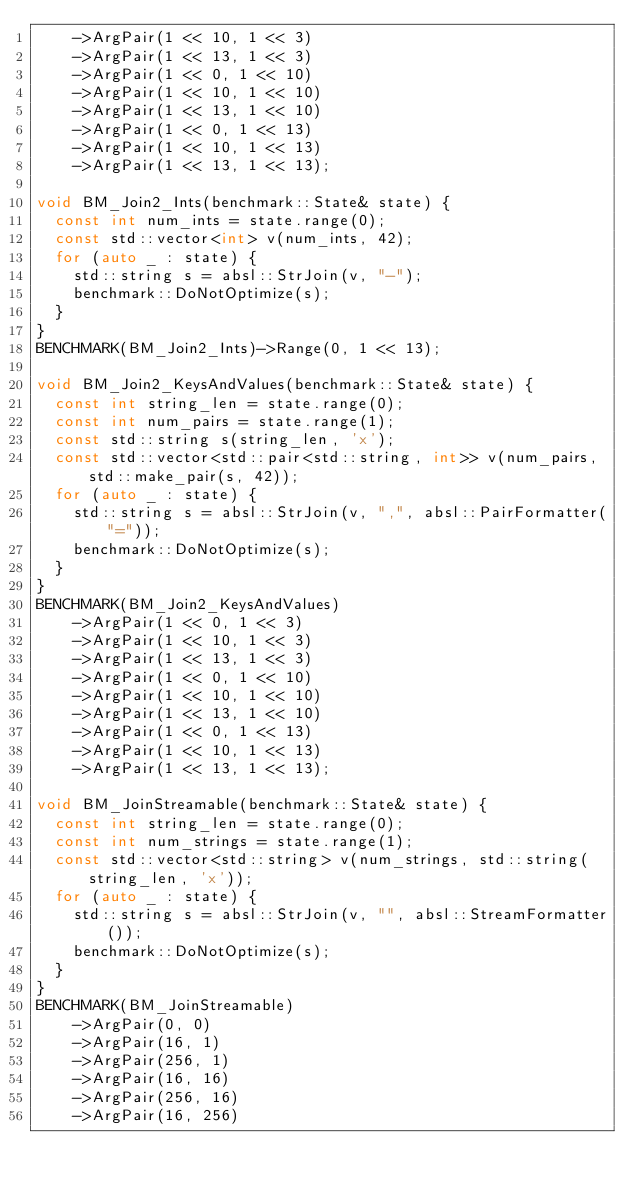<code> <loc_0><loc_0><loc_500><loc_500><_C++_>    ->ArgPair(1 << 10, 1 << 3)
    ->ArgPair(1 << 13, 1 << 3)
    ->ArgPair(1 << 0, 1 << 10)
    ->ArgPair(1 << 10, 1 << 10)
    ->ArgPair(1 << 13, 1 << 10)
    ->ArgPair(1 << 0, 1 << 13)
    ->ArgPair(1 << 10, 1 << 13)
    ->ArgPair(1 << 13, 1 << 13);

void BM_Join2_Ints(benchmark::State& state) {
  const int num_ints = state.range(0);
  const std::vector<int> v(num_ints, 42);
  for (auto _ : state) {
    std::string s = absl::StrJoin(v, "-");
    benchmark::DoNotOptimize(s);
  }
}
BENCHMARK(BM_Join2_Ints)->Range(0, 1 << 13);

void BM_Join2_KeysAndValues(benchmark::State& state) {
  const int string_len = state.range(0);
  const int num_pairs = state.range(1);
  const std::string s(string_len, 'x');
  const std::vector<std::pair<std::string, int>> v(num_pairs, std::make_pair(s, 42));
  for (auto _ : state) {
    std::string s = absl::StrJoin(v, ",", absl::PairFormatter("="));
    benchmark::DoNotOptimize(s);
  }
}
BENCHMARK(BM_Join2_KeysAndValues)
    ->ArgPair(1 << 0, 1 << 3)
    ->ArgPair(1 << 10, 1 << 3)
    ->ArgPair(1 << 13, 1 << 3)
    ->ArgPair(1 << 0, 1 << 10)
    ->ArgPair(1 << 10, 1 << 10)
    ->ArgPair(1 << 13, 1 << 10)
    ->ArgPair(1 << 0, 1 << 13)
    ->ArgPair(1 << 10, 1 << 13)
    ->ArgPair(1 << 13, 1 << 13);

void BM_JoinStreamable(benchmark::State& state) {
  const int string_len = state.range(0);
  const int num_strings = state.range(1);
  const std::vector<std::string> v(num_strings, std::string(string_len, 'x'));
  for (auto _ : state) {
    std::string s = absl::StrJoin(v, "", absl::StreamFormatter());
    benchmark::DoNotOptimize(s);
  }
}
BENCHMARK(BM_JoinStreamable)
    ->ArgPair(0, 0)
    ->ArgPair(16, 1)
    ->ArgPair(256, 1)
    ->ArgPair(16, 16)
    ->ArgPair(256, 16)
    ->ArgPair(16, 256)</code> 